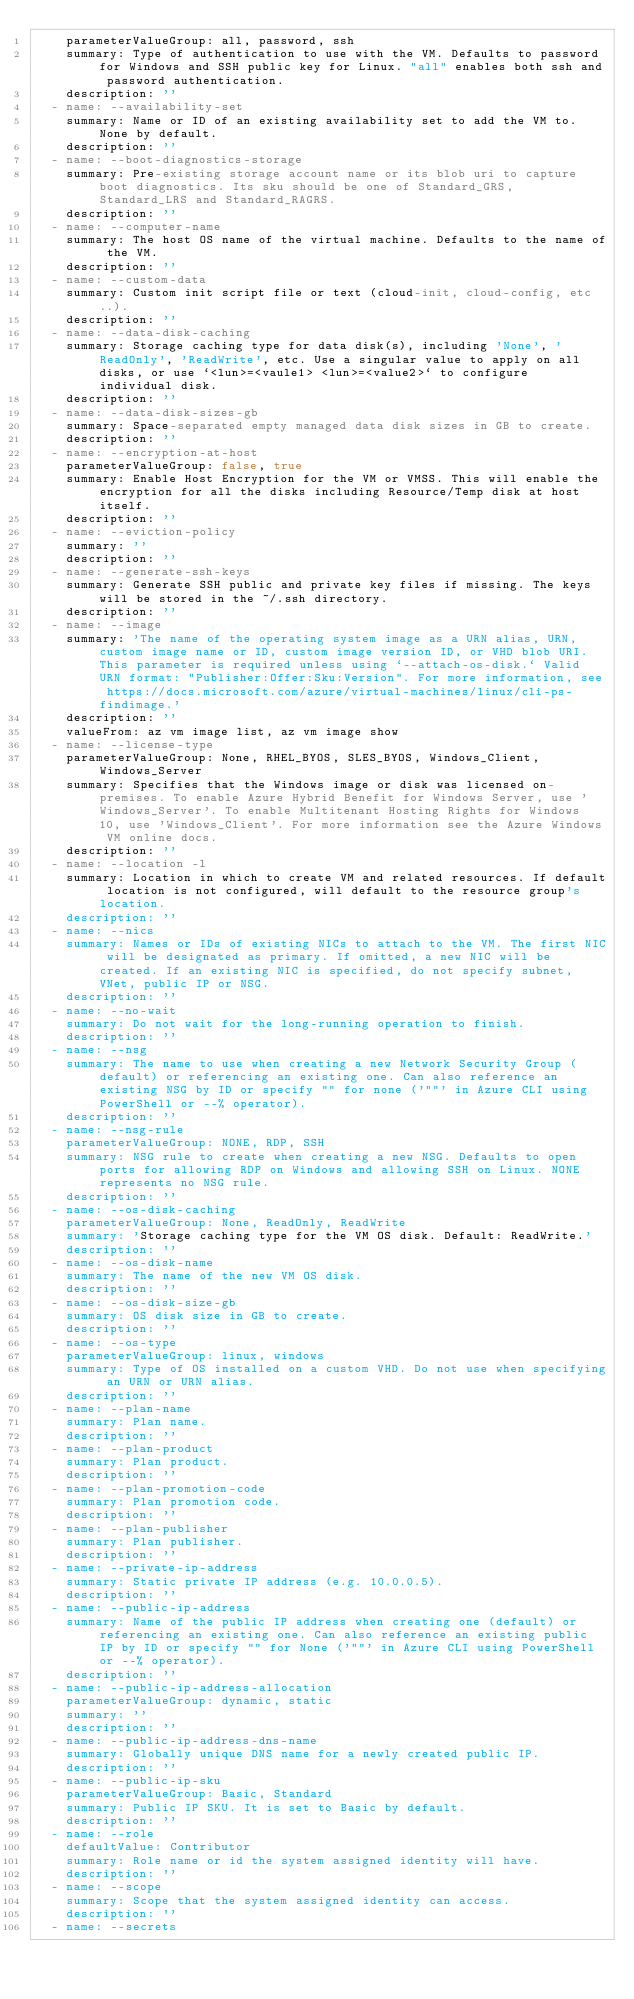<code> <loc_0><loc_0><loc_500><loc_500><_YAML_>    parameterValueGroup: all, password, ssh
    summary: Type of authentication to use with the VM. Defaults to password for Windows and SSH public key for Linux. "all" enables both ssh and password authentication.
    description: ''
  - name: --availability-set
    summary: Name or ID of an existing availability set to add the VM to. None by default.
    description: ''
  - name: --boot-diagnostics-storage
    summary: Pre-existing storage account name or its blob uri to capture boot diagnostics. Its sku should be one of Standard_GRS, Standard_LRS and Standard_RAGRS.
    description: ''
  - name: --computer-name
    summary: The host OS name of the virtual machine. Defaults to the name of the VM.
    description: ''
  - name: --custom-data
    summary: Custom init script file or text (cloud-init, cloud-config, etc..).
    description: ''
  - name: --data-disk-caching
    summary: Storage caching type for data disk(s), including 'None', 'ReadOnly', 'ReadWrite', etc. Use a singular value to apply on all disks, or use `<lun>=<vaule1> <lun>=<value2>` to configure individual disk.
    description: ''
  - name: --data-disk-sizes-gb
    summary: Space-separated empty managed data disk sizes in GB to create.
    description: ''
  - name: --encryption-at-host
    parameterValueGroup: false, true
    summary: Enable Host Encryption for the VM or VMSS. This will enable the encryption for all the disks including Resource/Temp disk at host itself.
    description: ''
  - name: --eviction-policy
    summary: ''
    description: ''
  - name: --generate-ssh-keys
    summary: Generate SSH public and private key files if missing. The keys will be stored in the ~/.ssh directory.
    description: ''
  - name: --image
    summary: 'The name of the operating system image as a URN alias, URN, custom image name or ID, custom image version ID, or VHD blob URI. This parameter is required unless using `--attach-os-disk.` Valid URN format: "Publisher:Offer:Sku:Version". For more information, see https://docs.microsoft.com/azure/virtual-machines/linux/cli-ps-findimage.'
    description: ''
    valueFrom: az vm image list, az vm image show
  - name: --license-type
    parameterValueGroup: None, RHEL_BYOS, SLES_BYOS, Windows_Client, Windows_Server
    summary: Specifies that the Windows image or disk was licensed on-premises. To enable Azure Hybrid Benefit for Windows Server, use 'Windows_Server'. To enable Multitenant Hosting Rights for Windows 10, use 'Windows_Client'. For more information see the Azure Windows VM online docs.
    description: ''
  - name: --location -l
    summary: Location in which to create VM and related resources. If default location is not configured, will default to the resource group's location.
    description: ''
  - name: --nics
    summary: Names or IDs of existing NICs to attach to the VM. The first NIC will be designated as primary. If omitted, a new NIC will be created. If an existing NIC is specified, do not specify subnet, VNet, public IP or NSG.
    description: ''
  - name: --no-wait
    summary: Do not wait for the long-running operation to finish.
    description: ''
  - name: --nsg
    summary: The name to use when creating a new Network Security Group (default) or referencing an existing one. Can also reference an existing NSG by ID or specify "" for none ('""' in Azure CLI using PowerShell or --% operator).
    description: ''
  - name: --nsg-rule
    parameterValueGroup: NONE, RDP, SSH
    summary: NSG rule to create when creating a new NSG. Defaults to open ports for allowing RDP on Windows and allowing SSH on Linux. NONE represents no NSG rule.
    description: ''
  - name: --os-disk-caching
    parameterValueGroup: None, ReadOnly, ReadWrite
    summary: 'Storage caching type for the VM OS disk. Default: ReadWrite.'
    description: ''
  - name: --os-disk-name
    summary: The name of the new VM OS disk.
    description: ''
  - name: --os-disk-size-gb
    summary: OS disk size in GB to create.
    description: ''
  - name: --os-type
    parameterValueGroup: linux, windows
    summary: Type of OS installed on a custom VHD. Do not use when specifying an URN or URN alias.
    description: ''
  - name: --plan-name
    summary: Plan name.
    description: ''
  - name: --plan-product
    summary: Plan product.
    description: ''
  - name: --plan-promotion-code
    summary: Plan promotion code.
    description: ''
  - name: --plan-publisher
    summary: Plan publisher.
    description: ''
  - name: --private-ip-address
    summary: Static private IP address (e.g. 10.0.0.5).
    description: ''
  - name: --public-ip-address
    summary: Name of the public IP address when creating one (default) or referencing an existing one. Can also reference an existing public IP by ID or specify "" for None ('""' in Azure CLI using PowerShell or --% operator).
    description: ''
  - name: --public-ip-address-allocation
    parameterValueGroup: dynamic, static
    summary: ''
    description: ''
  - name: --public-ip-address-dns-name
    summary: Globally unique DNS name for a newly created public IP.
    description: ''
  - name: --public-ip-sku
    parameterValueGroup: Basic, Standard
    summary: Public IP SKU. It is set to Basic by default.
    description: ''
  - name: --role
    defaultValue: Contributor
    summary: Role name or id the system assigned identity will have.
    description: ''
  - name: --scope
    summary: Scope that the system assigned identity can access.
    description: ''
  - name: --secrets</code> 